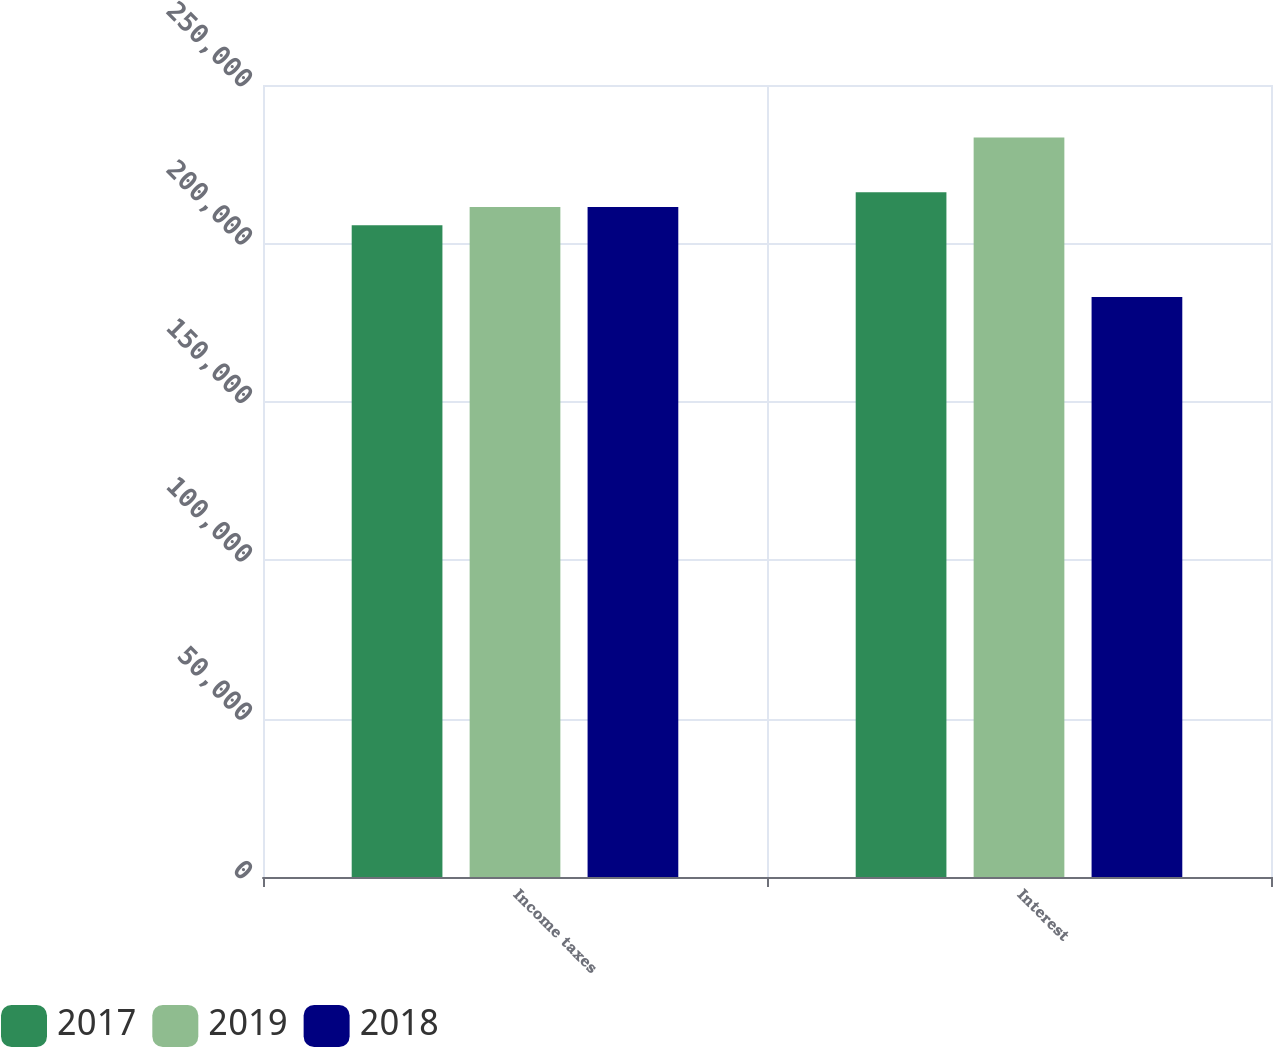<chart> <loc_0><loc_0><loc_500><loc_500><stacked_bar_chart><ecel><fcel>Income taxes<fcel>Interest<nl><fcel>2017<fcel>205762<fcel>216143<nl><fcel>2019<fcel>211473<fcel>233436<nl><fcel>2018<fcel>211473<fcel>183117<nl></chart> 